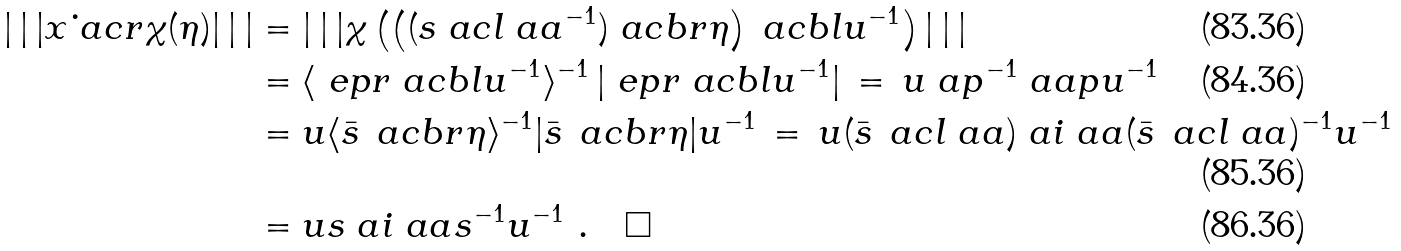Convert formula to latex. <formula><loc_0><loc_0><loc_500><loc_500>| \, | \, | x \dot { \ } a c r \chi ( \eta ) | \, | \, | & = | \, | \, | \chi \left ( \left ( ( s \ a c l \ a a ^ { - 1 } ) \ a c b r \eta \right ) \ a c b l u ^ { - 1 } \right ) | \, | \, | \\ & = \langle \ e p r \ a c b l u ^ { - 1 } \rangle ^ { - 1 } \, | \ e p r \ a c b l u ^ { - 1 } | \, = \, u \ a p ^ { - 1 } \ a a p u ^ { - 1 } \\ & = u \langle \bar { s } \, \ a c b r \eta \rangle ^ { - 1 } | \bar { s } \, \ a c b r \eta | u ^ { - 1 } \, = \, u ( \bar { s } \, \ a c l \ a a ) \ a i \ a a ( \bar { s } \, \ a c l \ a a ) ^ { - 1 } u ^ { - 1 } \\ & = u s \ a i \ a a s ^ { - 1 } u ^ { - 1 } \ . \quad \square</formula> 